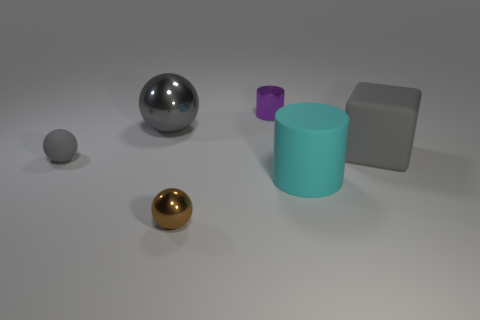What material is the large block that is the same color as the matte sphere?
Your answer should be compact. Rubber. There is a purple cylinder that is the same size as the brown metallic object; what is it made of?
Keep it short and to the point. Metal. How many other objects are the same color as the big sphere?
Keep it short and to the point. 2. What number of cubes are there?
Your answer should be compact. 1. What number of objects are both behind the tiny brown thing and in front of the small gray matte ball?
Offer a very short reply. 1. What is the large ball made of?
Offer a very short reply. Metal. Are there any big cyan matte cylinders?
Offer a terse response. Yes. What is the color of the thing that is right of the cyan cylinder?
Make the answer very short. Gray. There is a small thing in front of the cylinder that is in front of the tiny gray object; what number of big gray spheres are on the right side of it?
Offer a terse response. 0. There is a tiny thing that is on the left side of the purple shiny cylinder and behind the big matte cylinder; what is its material?
Keep it short and to the point. Rubber. 